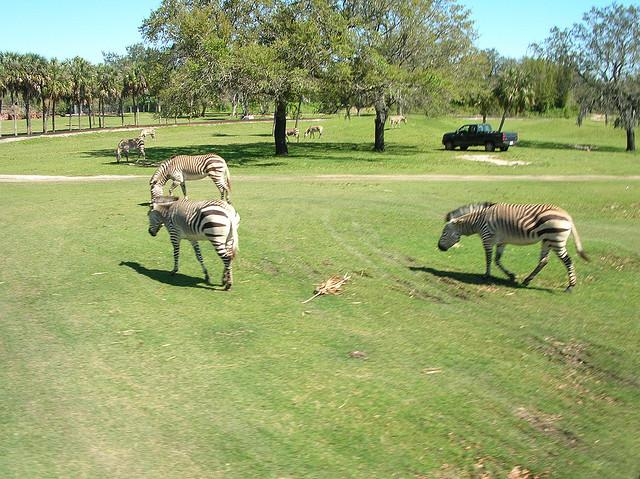What do the animals have? stripes 